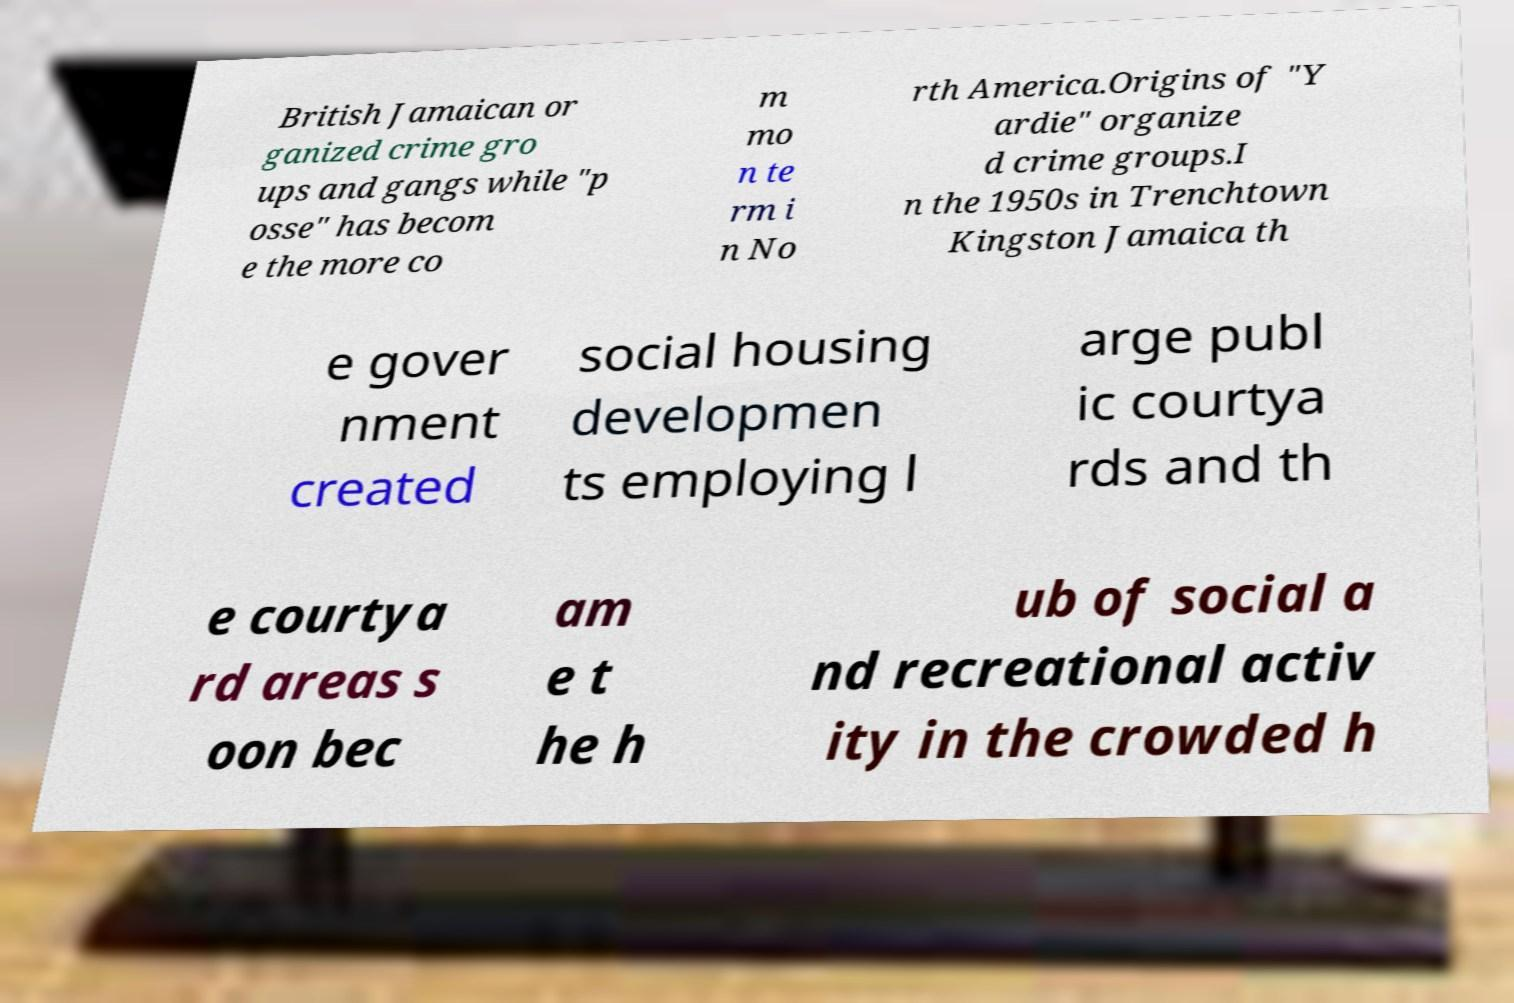There's text embedded in this image that I need extracted. Can you transcribe it verbatim? British Jamaican or ganized crime gro ups and gangs while "p osse" has becom e the more co m mo n te rm i n No rth America.Origins of "Y ardie" organize d crime groups.I n the 1950s in Trenchtown Kingston Jamaica th e gover nment created social housing developmen ts employing l arge publ ic courtya rds and th e courtya rd areas s oon bec am e t he h ub of social a nd recreational activ ity in the crowded h 